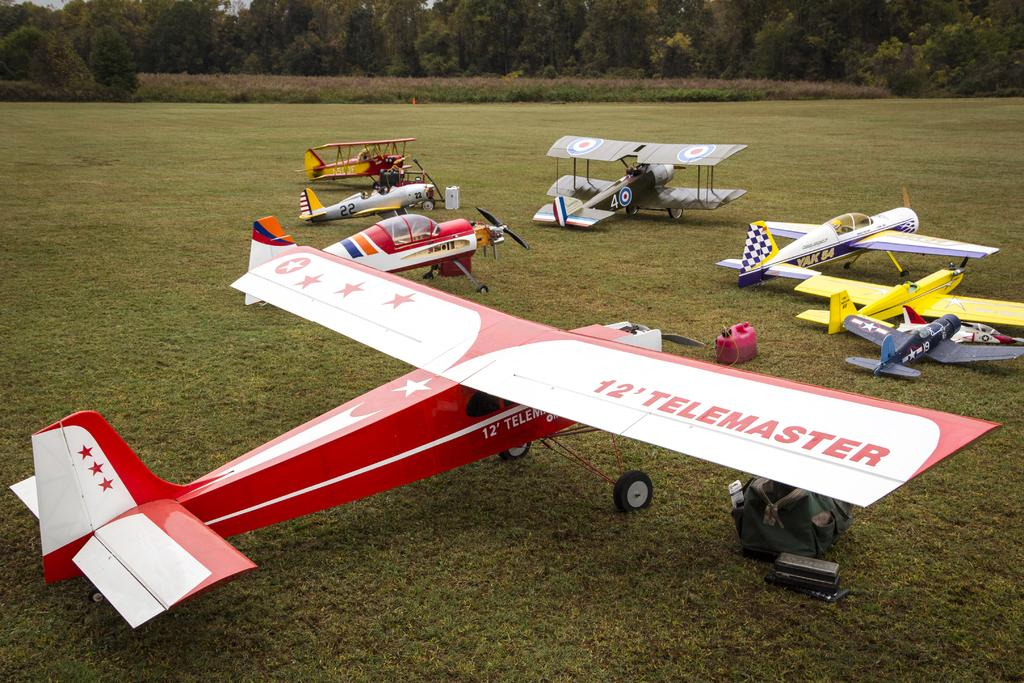What is the main subject of the image? The main subject of the image is airplanes. Where are the airplanes located? The airplanes are on the grass. What else can be seen in the image besides the airplanes? There are trees in the image. How many cherries are on top of the pizzas in the image? There are no pizzas or cherries present in the image; it features airplanes on the grass with trees in the background. 